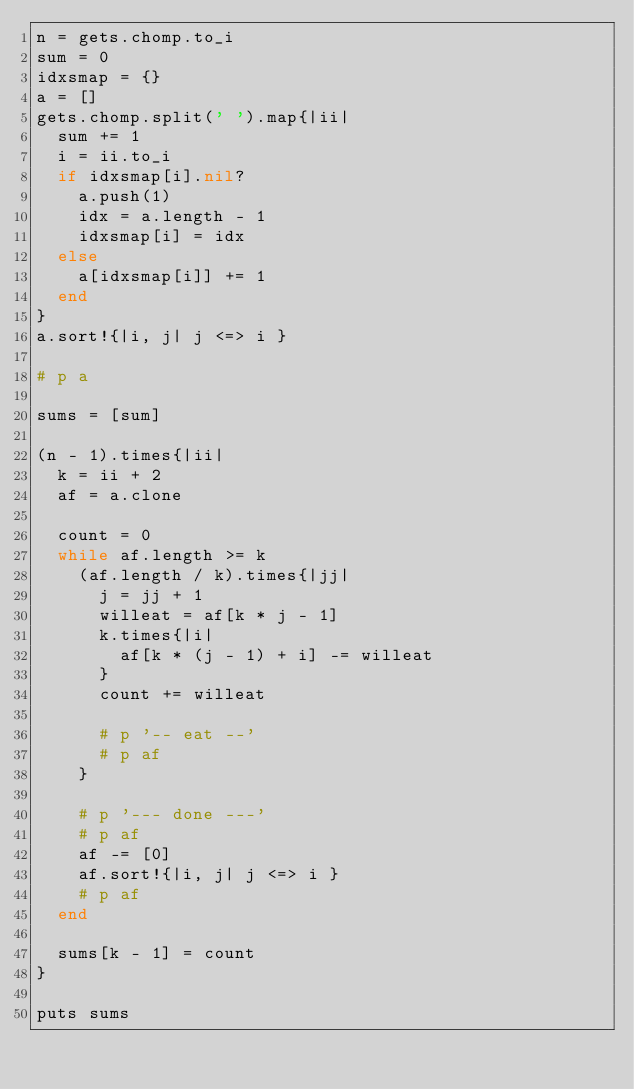<code> <loc_0><loc_0><loc_500><loc_500><_Ruby_>n = gets.chomp.to_i
sum = 0
idxsmap = {}
a = []
gets.chomp.split(' ').map{|ii|
  sum += 1
  i = ii.to_i
  if idxsmap[i].nil?
    a.push(1)
    idx = a.length - 1
    idxsmap[i] = idx
  else
    a[idxsmap[i]] += 1
  end
}
a.sort!{|i, j| j <=> i }

# p a

sums = [sum]

(n - 1).times{|ii|
  k = ii + 2
  af = a.clone

  count = 0
  while af.length >= k
    (af.length / k).times{|jj|
      j = jj + 1
      willeat = af[k * j - 1]
      k.times{|i|
        af[k * (j - 1) + i] -= willeat
      }
      count += willeat

      # p '-- eat --'
      # p af
    }

    # p '--- done ---'
    # p af
    af -= [0]
    af.sort!{|i, j| j <=> i }
    # p af
  end

  sums[k - 1] = count
}

puts sums
</code> 